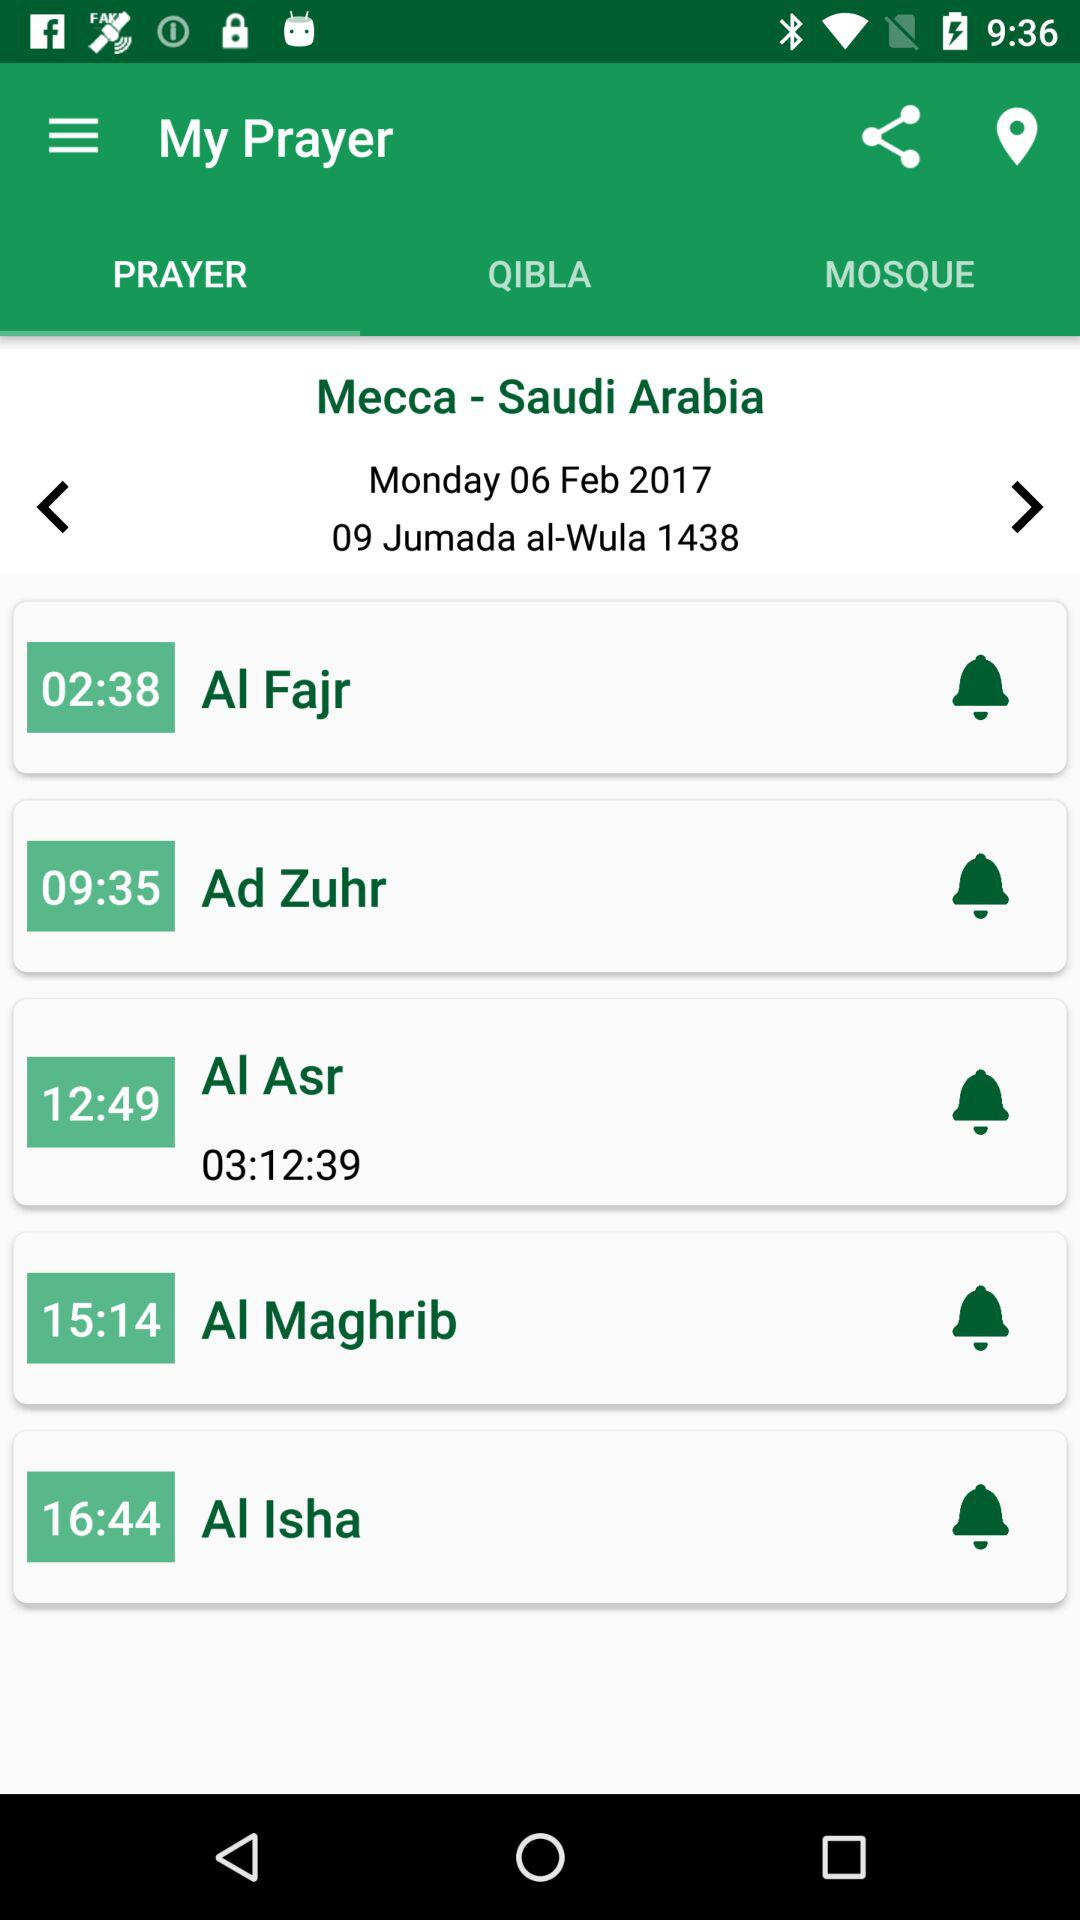How many hours are between the Maghrib and Isha prayers?
Answer the question using a single word or phrase. 1 hour and 30 minutes 